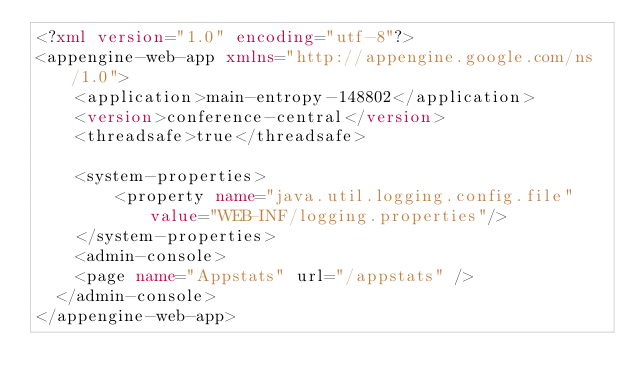<code> <loc_0><loc_0><loc_500><loc_500><_XML_><?xml version="1.0" encoding="utf-8"?>
<appengine-web-app xmlns="http://appengine.google.com/ns/1.0">
    <application>main-entropy-148802</application>
    <version>conference-central</version>
    <threadsafe>true</threadsafe>

    <system-properties>
        <property name="java.util.logging.config.file" value="WEB-INF/logging.properties"/>
    </system-properties>
    <admin-console>
	  <page name="Appstats" url="/appstats" />
	</admin-console>
</appengine-web-app>
</code> 